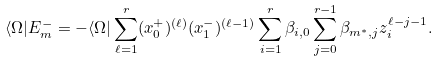Convert formula to latex. <formula><loc_0><loc_0><loc_500><loc_500>\langle \Omega | { E } _ { m } ^ { - } = - \langle \Omega | \sum _ { \ell = 1 } ^ { r } ( { x } _ { 0 } ^ { + } ) ^ { ( \ell ) } ( { x } _ { 1 } ^ { - } ) ^ { ( \ell - 1 ) } \sum _ { i = 1 } ^ { r } \beta _ { i , 0 } \sum _ { j = 0 } ^ { r - 1 } \beta _ { m ^ { \ast } , j } z _ { i } ^ { \ell - j - 1 } .</formula> 